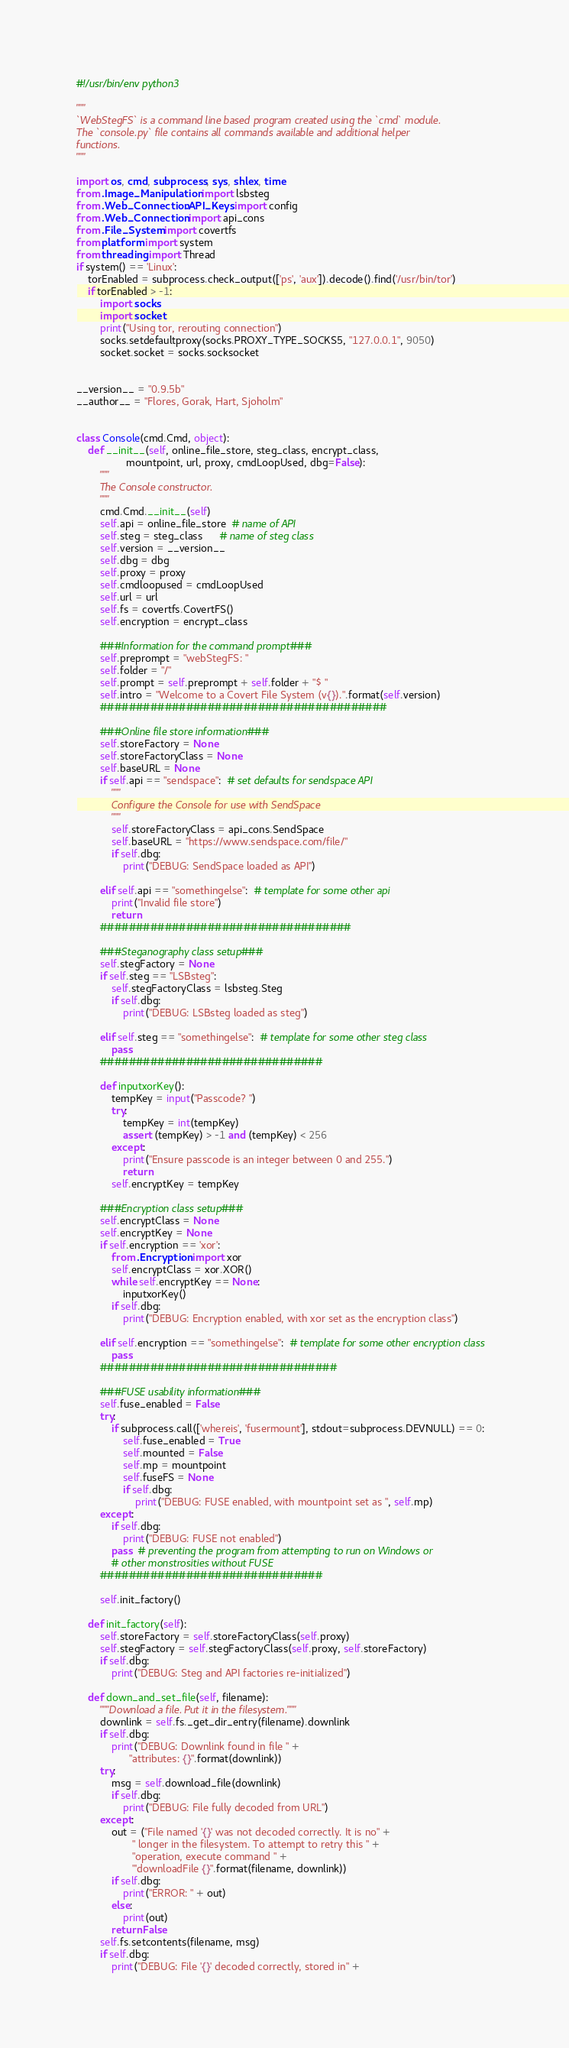<code> <loc_0><loc_0><loc_500><loc_500><_Python_>#!/usr/bin/env python3

"""
`WebStegFS` is a command line based program created using the `cmd` module.
The `console.py` file contains all commands available and additional helper
functions.
"""

import os, cmd, subprocess, sys, shlex, time
from .Image_Manipulation import lsbsteg
from .Web_Connection.API_Keys import config
from .Web_Connection import api_cons
from .File_System import covertfs
from platform import system
from threading import Thread
if system() == 'Linux':
    torEnabled = subprocess.check_output(['ps', 'aux']).decode().find('/usr/bin/tor')
    if torEnabled > -1:
        import socks
        import socket
        print("Using tor, rerouting connection")
        socks.setdefaultproxy(socks.PROXY_TYPE_SOCKS5, "127.0.0.1", 9050)
        socket.socket = socks.socksocket


__version__ = "0.9.5b"
__author__ = "Flores, Gorak, Hart, Sjoholm"


class Console(cmd.Cmd, object):
    def __init__(self, online_file_store, steg_class, encrypt_class,
                 mountpoint, url, proxy, cmdLoopUsed, dbg=False):
        """
        The Console constructor.
        """
        cmd.Cmd.__init__(self)
        self.api = online_file_store  # name of API
        self.steg = steg_class      # name of steg class
        self.version = __version__
        self.dbg = dbg
        self.proxy = proxy
        self.cmdloopused = cmdLoopUsed
        self.url = url
        self.fs = covertfs.CovertFS()
        self.encryption = encrypt_class

        ###Information for the command prompt###
        self.preprompt = "webStegFS: "
        self.folder = "/"
        self.prompt = self.preprompt + self.folder + "$ "
        self.intro = "Welcome to a Covert File System (v{}).".format(self.version)
        ########################################

        ###Online file store information###
        self.storeFactory = None
        self.storeFactoryClass = None
        self.baseURL = None
        if self.api == "sendspace":  # set defaults for sendspace API
            """
            Configure the Console for use with SendSpace
            """
            self.storeFactoryClass = api_cons.SendSpace
            self.baseURL = "https://www.sendspace.com/file/"
            if self.dbg:
                print("DEBUG: SendSpace loaded as API")

        elif self.api == "somethingelse":  # template for some other api
            print("Invalid file store")
            return
        ###################################

        ###Steganography class setup###
        self.stegFactory = None
        if self.steg == "LSBsteg":
            self.stegFactoryClass = lsbsteg.Steg
            if self.dbg:
                print("DEBUG: LSBsteg loaded as steg")

        elif self.steg == "somethingelse":  # template for some other steg class
            pass
        ###############################

        def inputxorKey():
            tempKey = input("Passcode? ")
            try:
                tempKey = int(tempKey)
                assert (tempKey) > -1 and (tempKey) < 256
            except:
                print("Ensure passcode is an integer between 0 and 255.")
                return
            self.encryptKey = tempKey

        ###Encryption class setup###
        self.encryptClass = None
        self.encryptKey = None
        if self.encryption == 'xor':
            from .Encryption import xor
            self.encryptClass = xor.XOR()
            while self.encryptKey == None:
                inputxorKey()
            if self.dbg:
                print("DEBUG: Encryption enabled, with xor set as the encryption class")

        elif self.encryption == "somethingelse":  # template for some other encryption class
            pass
        #################################

        ###FUSE usability information###
        self.fuse_enabled = False
        try:
            if subprocess.call(['whereis', 'fusermount'], stdout=subprocess.DEVNULL) == 0:
                self.fuse_enabled = True
                self.mounted = False
                self.mp = mountpoint
                self.fuseFS = None
                if self.dbg:
                    print("DEBUG: FUSE enabled, with mountpoint set as ", self.mp)
        except:
            if self.dbg:
                print("DEBUG: FUSE not enabled")
            pass  # preventing the program from attempting to run on Windows or
            # other monstrosities without FUSE
        ###############################

        self.init_factory()

    def init_factory(self):
        self.storeFactory = self.storeFactoryClass(self.proxy)
        self.stegFactory = self.stegFactoryClass(self.proxy, self.storeFactory)
        if self.dbg:
            print("DEBUG: Steg and API factories re-initialized")

    def down_and_set_file(self, filename):
        """Download a file. Put it in the filesystem."""
        downlink = self.fs._get_dir_entry(filename).downlink
        if self.dbg:
            print("DEBUG: Downlink found in file " +
                  "attributes: {}".format(downlink))
        try:
            msg = self.download_file(downlink)
            if self.dbg:
                print("DEBUG: File fully decoded from URL")
        except:
            out = ("File named '{}' was not decoded correctly. It is no" +
                   " longer in the filesystem. To attempt to retry this " +
                   "operation, execute command " +
                   "'downloadFile {}".format(filename, downlink))
            if self.dbg:
                print("ERROR: " + out)
            else:
                print(out)
            return False
        self.fs.setcontents(filename, msg)
        if self.dbg:
            print("DEBUG: File '{}' decoded correctly, stored in" +</code> 